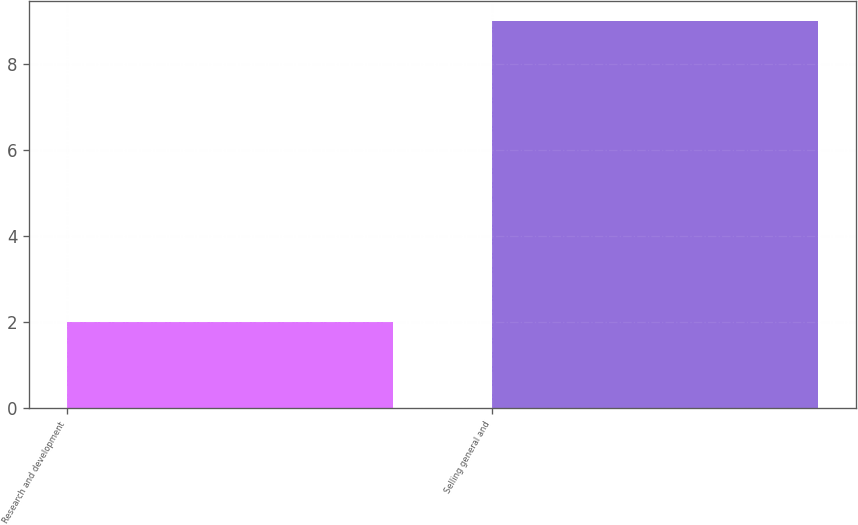Convert chart. <chart><loc_0><loc_0><loc_500><loc_500><bar_chart><fcel>Research and development<fcel>Selling general and<nl><fcel>2<fcel>9<nl></chart> 